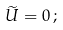<formula> <loc_0><loc_0><loc_500><loc_500>\widetilde { U } = 0 \, ;</formula> 